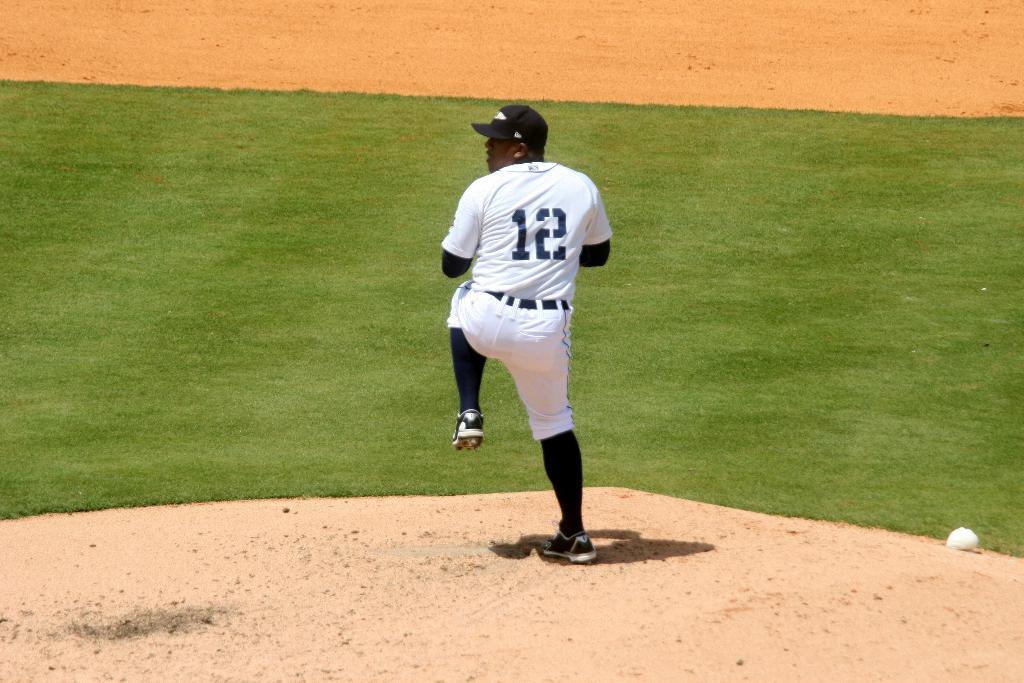What number shirt is this baseball player wearing?
Your answer should be compact. 12. What is the first number?
Your answer should be compact. 1. 